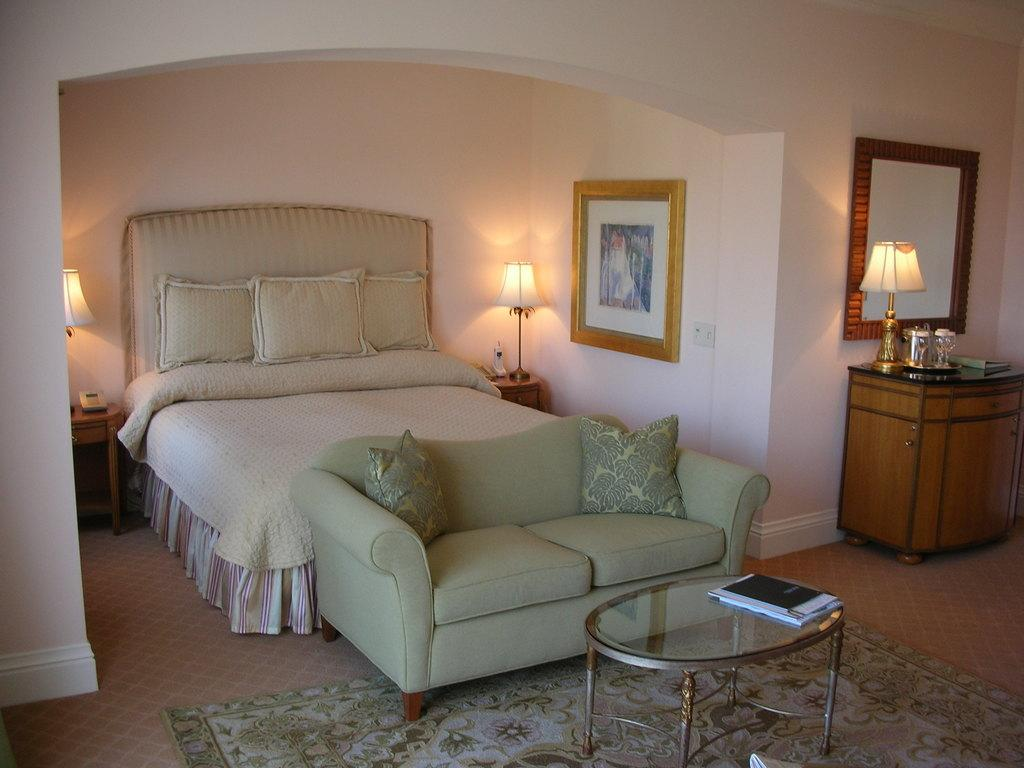What type of room is shown in the image? The image depicts a bedroom. What can be found on the bed in the room? There are three pillows on the bed in the room. How many lamps are in the room, and where are they located? There are two lamps in the room, one on each side of the bed. What is hanging on the wall in the room? There is a photo frame on the wall. What type of seating is available in the room? There is a sofa in front of the bed. What furniture is present in the room for storage or display purposes? There is a table and a cupboard with a lamp on it in the room. How many babies are crawling on the floor in the image? There are no babies present in the image; it depicts a bedroom with furniture and decorations. What type of expansion is visible in the image? There is no expansion visible in the image; it shows a bedroom with standard-sized furniture and decorations. 